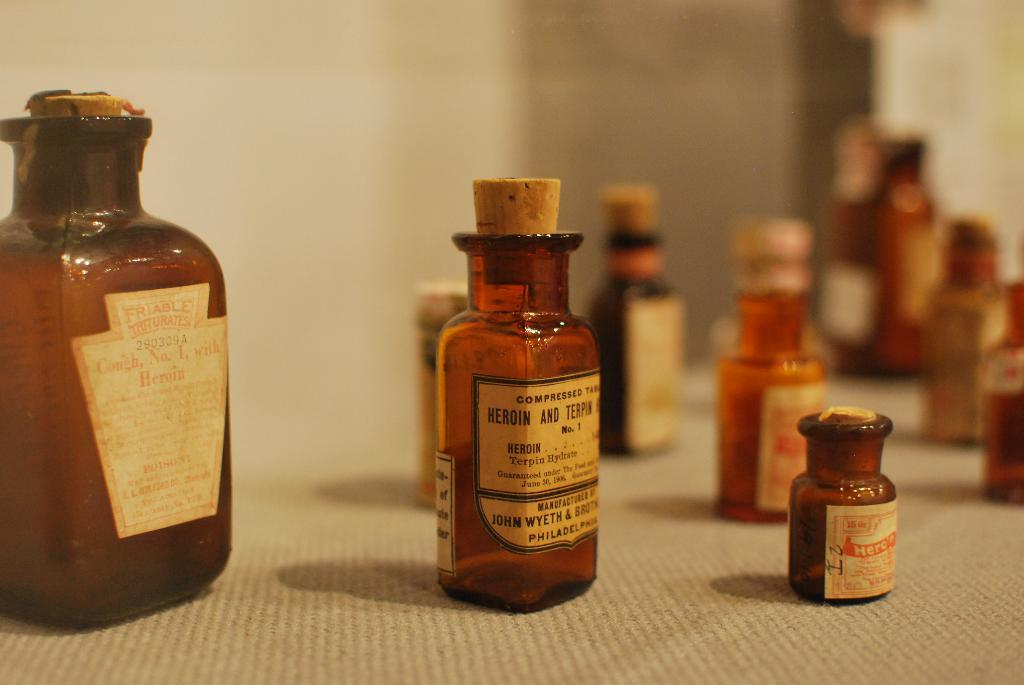<image>
Provide a brief description of the given image. An old bottle of Cough No 1. with heroin sits on display with other bottles 